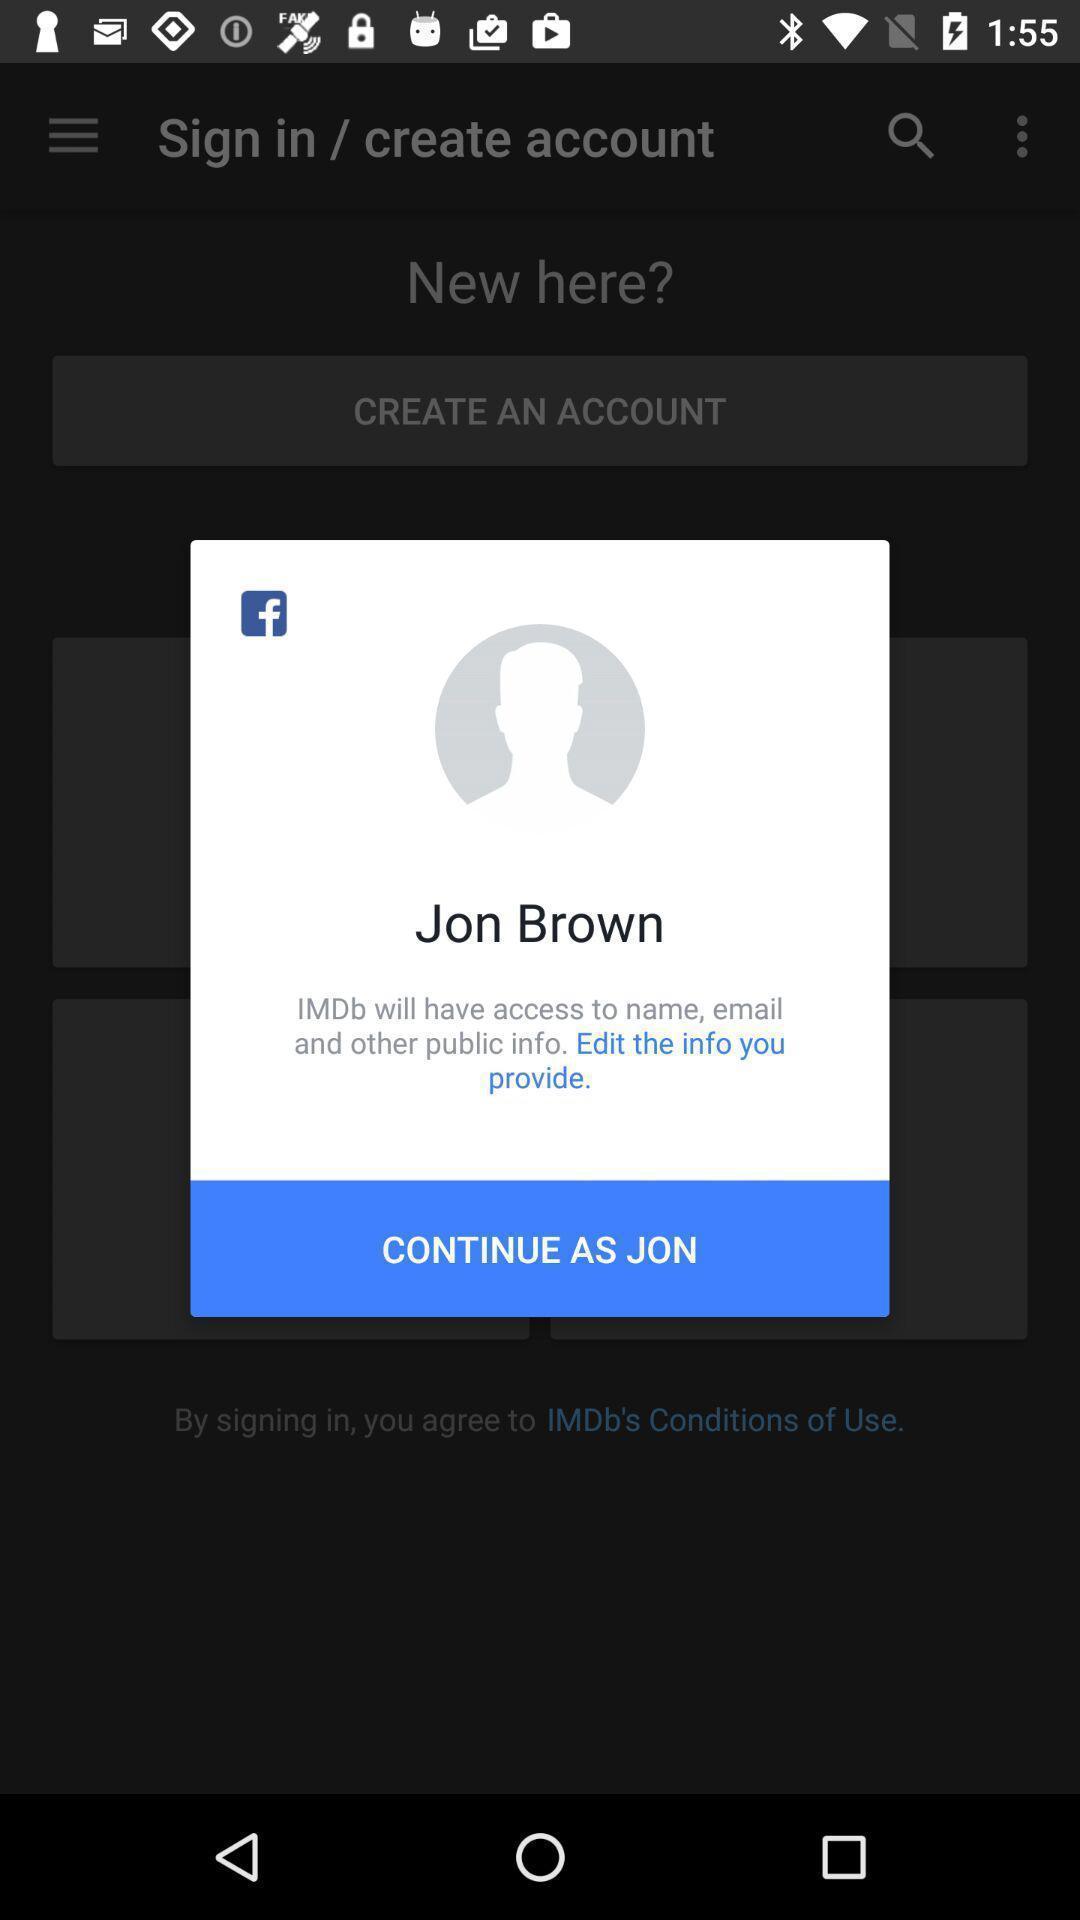Explain the elements present in this screenshot. Pop-up showing option like continue. 